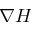Convert formula to latex. <formula><loc_0><loc_0><loc_500><loc_500>\nabla H</formula> 